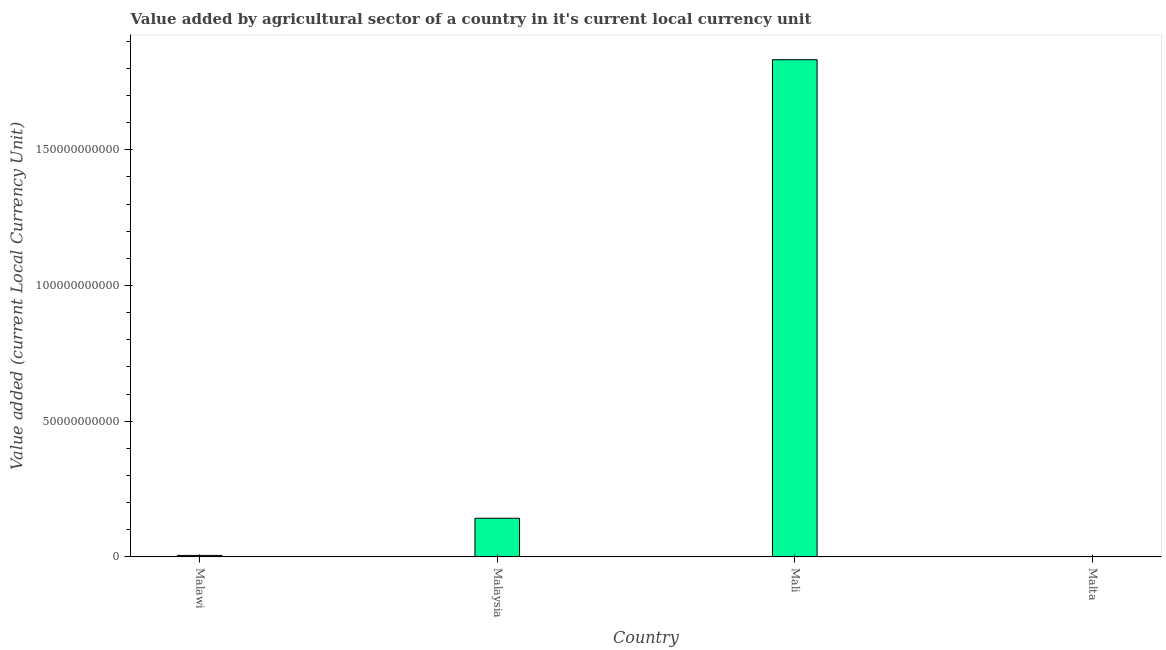What is the title of the graph?
Provide a short and direct response. Value added by agricultural sector of a country in it's current local currency unit. What is the label or title of the X-axis?
Ensure brevity in your answer.  Country. What is the label or title of the Y-axis?
Your response must be concise. Value added (current Local Currency Unit). What is the value added by agriculture sector in Malaysia?
Your answer should be compact. 1.42e+1. Across all countries, what is the maximum value added by agriculture sector?
Provide a short and direct response. 1.83e+11. Across all countries, what is the minimum value added by agriculture sector?
Keep it short and to the point. 4.94e+07. In which country was the value added by agriculture sector maximum?
Ensure brevity in your answer.  Mali. In which country was the value added by agriculture sector minimum?
Offer a very short reply. Malta. What is the sum of the value added by agriculture sector?
Give a very brief answer. 1.98e+11. What is the difference between the value added by agriculture sector in Malawi and Malta?
Your response must be concise. 4.99e+08. What is the average value added by agriculture sector per country?
Provide a succinct answer. 4.95e+1. What is the median value added by agriculture sector?
Make the answer very short. 7.40e+09. In how many countries, is the value added by agriculture sector greater than 110000000000 LCU?
Your answer should be very brief. 1. What is the ratio of the value added by agriculture sector in Malaysia to that in Mali?
Your answer should be compact. 0.08. Is the value added by agriculture sector in Malawi less than that in Malaysia?
Your answer should be compact. Yes. What is the difference between the highest and the second highest value added by agriculture sector?
Offer a terse response. 1.69e+11. Is the sum of the value added by agriculture sector in Malaysia and Malta greater than the maximum value added by agriculture sector across all countries?
Offer a terse response. No. What is the difference between the highest and the lowest value added by agriculture sector?
Keep it short and to the point. 1.83e+11. In how many countries, is the value added by agriculture sector greater than the average value added by agriculture sector taken over all countries?
Your answer should be compact. 1. What is the Value added (current Local Currency Unit) of Malawi?
Give a very brief answer. 5.49e+08. What is the Value added (current Local Currency Unit) of Malaysia?
Ensure brevity in your answer.  1.42e+1. What is the Value added (current Local Currency Unit) of Mali?
Ensure brevity in your answer.  1.83e+11. What is the Value added (current Local Currency Unit) in Malta?
Provide a succinct answer. 4.94e+07. What is the difference between the Value added (current Local Currency Unit) in Malawi and Malaysia?
Give a very brief answer. -1.37e+1. What is the difference between the Value added (current Local Currency Unit) in Malawi and Mali?
Give a very brief answer. -1.83e+11. What is the difference between the Value added (current Local Currency Unit) in Malawi and Malta?
Provide a short and direct response. 4.99e+08. What is the difference between the Value added (current Local Currency Unit) in Malaysia and Mali?
Your response must be concise. -1.69e+11. What is the difference between the Value added (current Local Currency Unit) in Malaysia and Malta?
Your response must be concise. 1.42e+1. What is the difference between the Value added (current Local Currency Unit) in Mali and Malta?
Ensure brevity in your answer.  1.83e+11. What is the ratio of the Value added (current Local Currency Unit) in Malawi to that in Malaysia?
Ensure brevity in your answer.  0.04. What is the ratio of the Value added (current Local Currency Unit) in Malawi to that in Mali?
Your response must be concise. 0. What is the ratio of the Value added (current Local Currency Unit) in Malawi to that in Malta?
Make the answer very short. 11.11. What is the ratio of the Value added (current Local Currency Unit) in Malaysia to that in Mali?
Keep it short and to the point. 0.08. What is the ratio of the Value added (current Local Currency Unit) in Malaysia to that in Malta?
Your answer should be very brief. 288.41. What is the ratio of the Value added (current Local Currency Unit) in Mali to that in Malta?
Your answer should be very brief. 3708.27. 